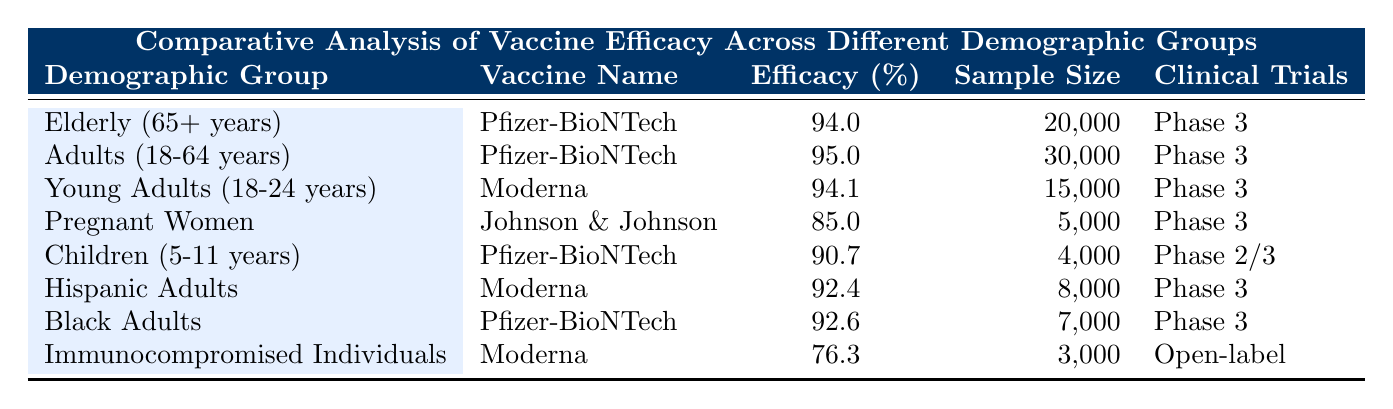What is the efficacy percentage for Black Adults receiving the Pfizer-BioNTech vaccine? The table indicates that the efficacy percentage for Black Adults receiving the Pfizer-BioNTech vaccine is specifically listed in the row for that demographic group. It shows an efficacy of 92.6%.
Answer: 92.6% Which vaccine has the lowest efficacy percentage among the listed populations? To determine the lowest efficacy, we review the efficacy percentages from all the entries. The lowest efficacy is seen for Immunocompromised Individuals with the Moderna vaccine, which is listed as 76.3%.
Answer: 76.3% Is the sample size for Pregnant Women greater than for Young Adults? The sample size for Pregnant Women is 5,000, while for Young Adults, it's 15,000. Since 5,000 is less than 15,000, the statement is false.
Answer: No What is the average efficacy percentage of the vaccines for adults aged 18-64 years? The efficacy for Adults (18-64 years) is listed as 95%. Since the table does not provide other adult age groups specifically aged 18-64 years, we consider only this data point. Therefore, the average efficacy remains 95% because there is only one value.
Answer: 95% Do both vaccines (Pfizer-BioNTech and Moderna) show efficacy of 90% or higher for demographic groups in the study? Review each demographic's efficacy: Pfizer-BioNTech has percentages of 94.0, 95.0, 90.7, and 92.6, and Moderna has 94.1, 92.4, and 76.3. All but one (76.3 for Immunocompromised) are 90% or higher. Thus, yes, both vaccines meet the criterion.
Answer: Yes What is the difference in efficacy between the Pfizer-BioNTech vaccine for Adults and the Johnson & Johnson vaccine for Pregnant Women? The efficacy of Pfizer-BioNTech for Adults is 95%, while Johnson & Johnson for Pregnant Women is 85%. To find the difference: 95% - 85% = 10%. Thus, the difference in efficacy is 10%.
Answer: 10% How many demographic groups are represented in the table with a sample size greater than 7,000? We filter the entries based on the sample size criteria. Only the groups Elderly (20,000), Adults (30,000), Young Adults (15,000), Hispanic Adults (8,000), and Black Adults (7,000) exceed 7,000. This totals to five groups.
Answer: 5 Which vaccine has the highest efficacy and for which demographic group was it tested? The efficacy percentages are reviewed, with Pfizer-BioNTech for Adults (95%) being the highest. This indicates that the Pfizer-BioNTech vaccine for Adults has the highest efficacy among the data provided.
Answer: Pfizer-BioNTech for Adults 